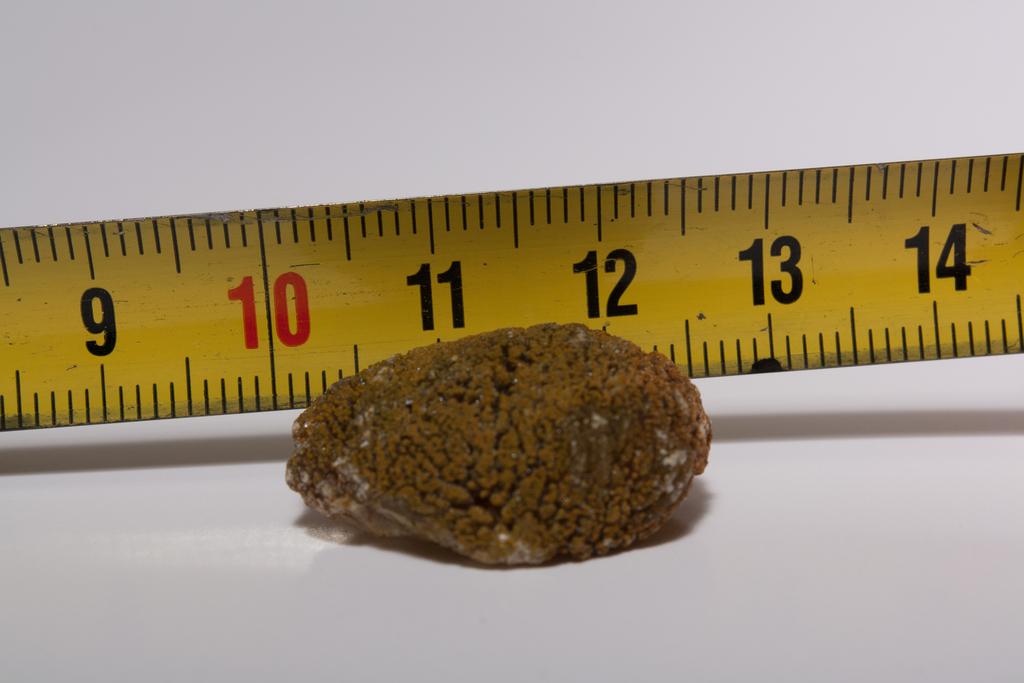What number is in the center above the rock?
Your response must be concise. 11. What number is in red?
Make the answer very short. 10. 